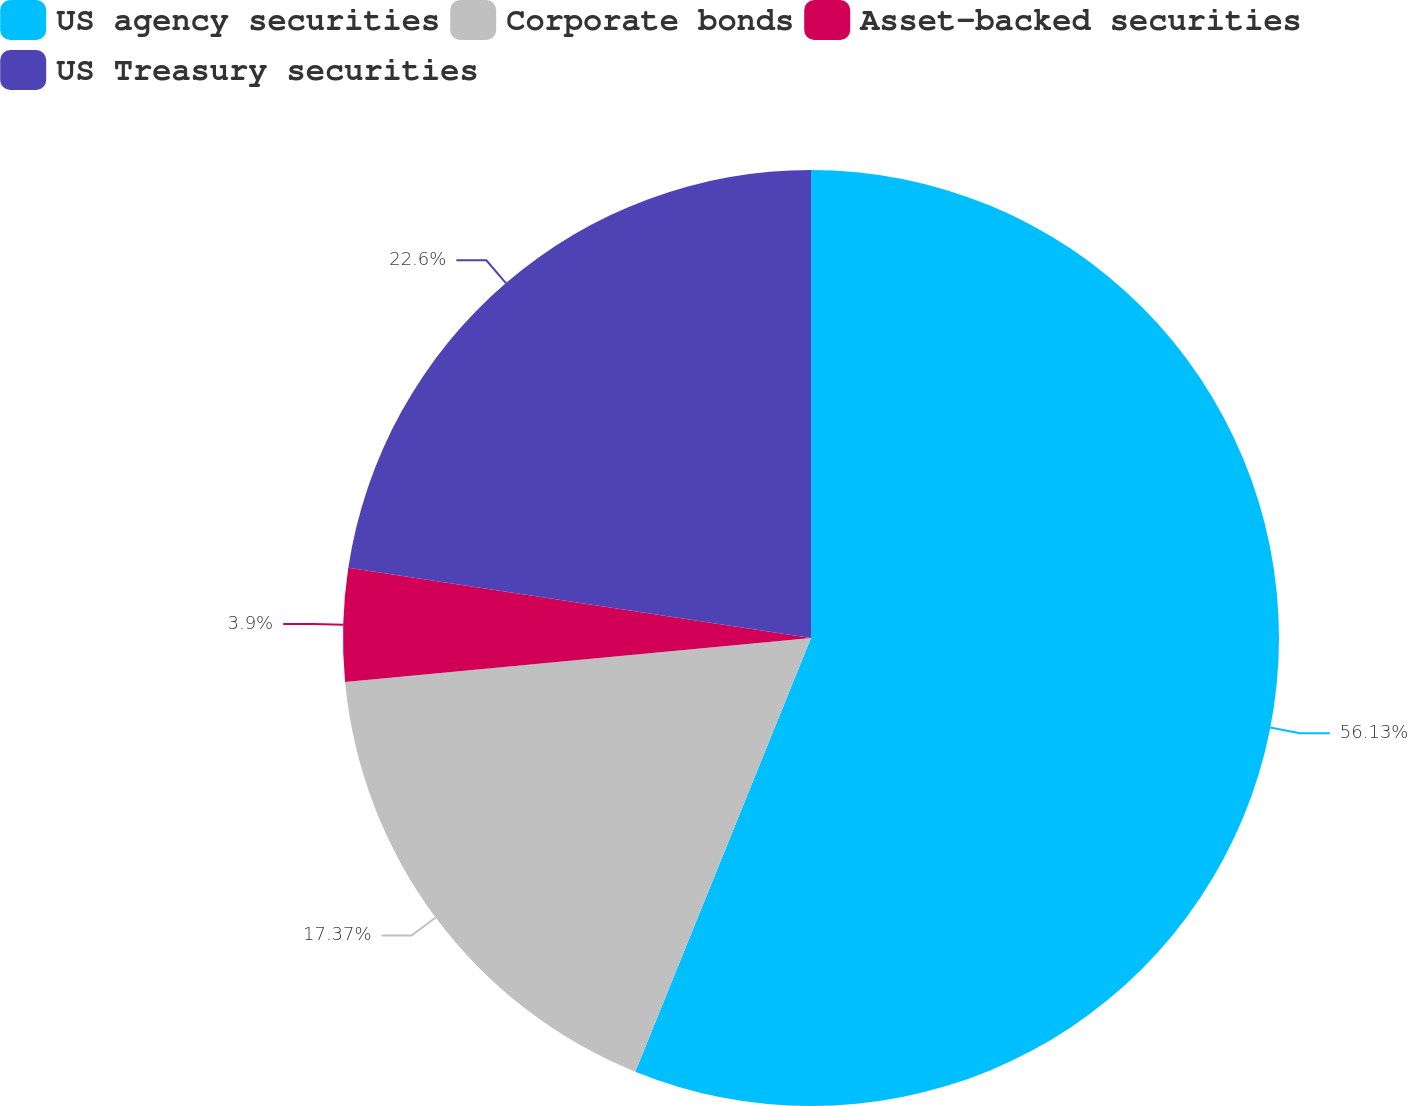Convert chart. <chart><loc_0><loc_0><loc_500><loc_500><pie_chart><fcel>US agency securities<fcel>Corporate bonds<fcel>Asset-backed securities<fcel>US Treasury securities<nl><fcel>56.12%<fcel>17.37%<fcel>3.9%<fcel>22.6%<nl></chart> 